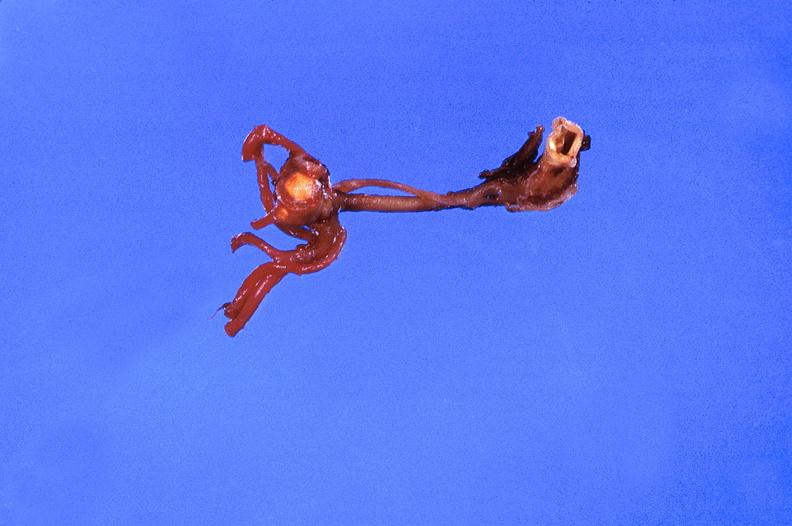s this section showing liver with tumor mass in hilar area tumor present?
Answer the question using a single word or phrase. No 